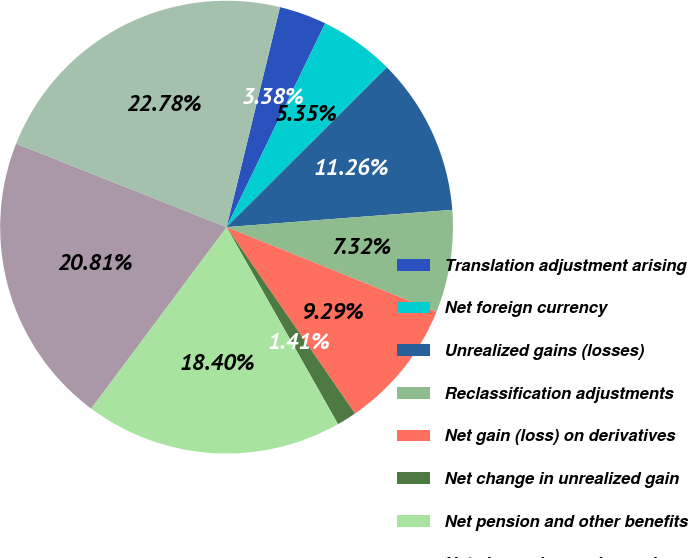Convert chart. <chart><loc_0><loc_0><loc_500><loc_500><pie_chart><fcel>Translation adjustment arising<fcel>Net foreign currency<fcel>Unrealized gains (losses)<fcel>Reclassification adjustments<fcel>Net gain (loss) on derivatives<fcel>Net change in unrealized gain<fcel>Net pension and other benefits<fcel>Net change in pension and<fcel>Other comprehensive income<nl><fcel>3.38%<fcel>5.35%<fcel>11.26%<fcel>7.32%<fcel>9.29%<fcel>1.41%<fcel>18.4%<fcel>20.81%<fcel>22.78%<nl></chart> 